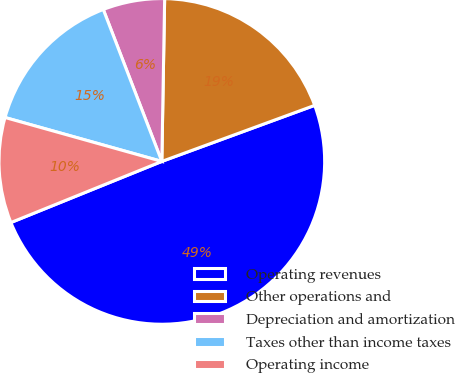Convert chart to OTSL. <chart><loc_0><loc_0><loc_500><loc_500><pie_chart><fcel>Operating revenues<fcel>Other operations and<fcel>Depreciation and amortization<fcel>Taxes other than income taxes<fcel>Operating income<nl><fcel>49.47%<fcel>19.13%<fcel>6.13%<fcel>14.8%<fcel>10.47%<nl></chart> 